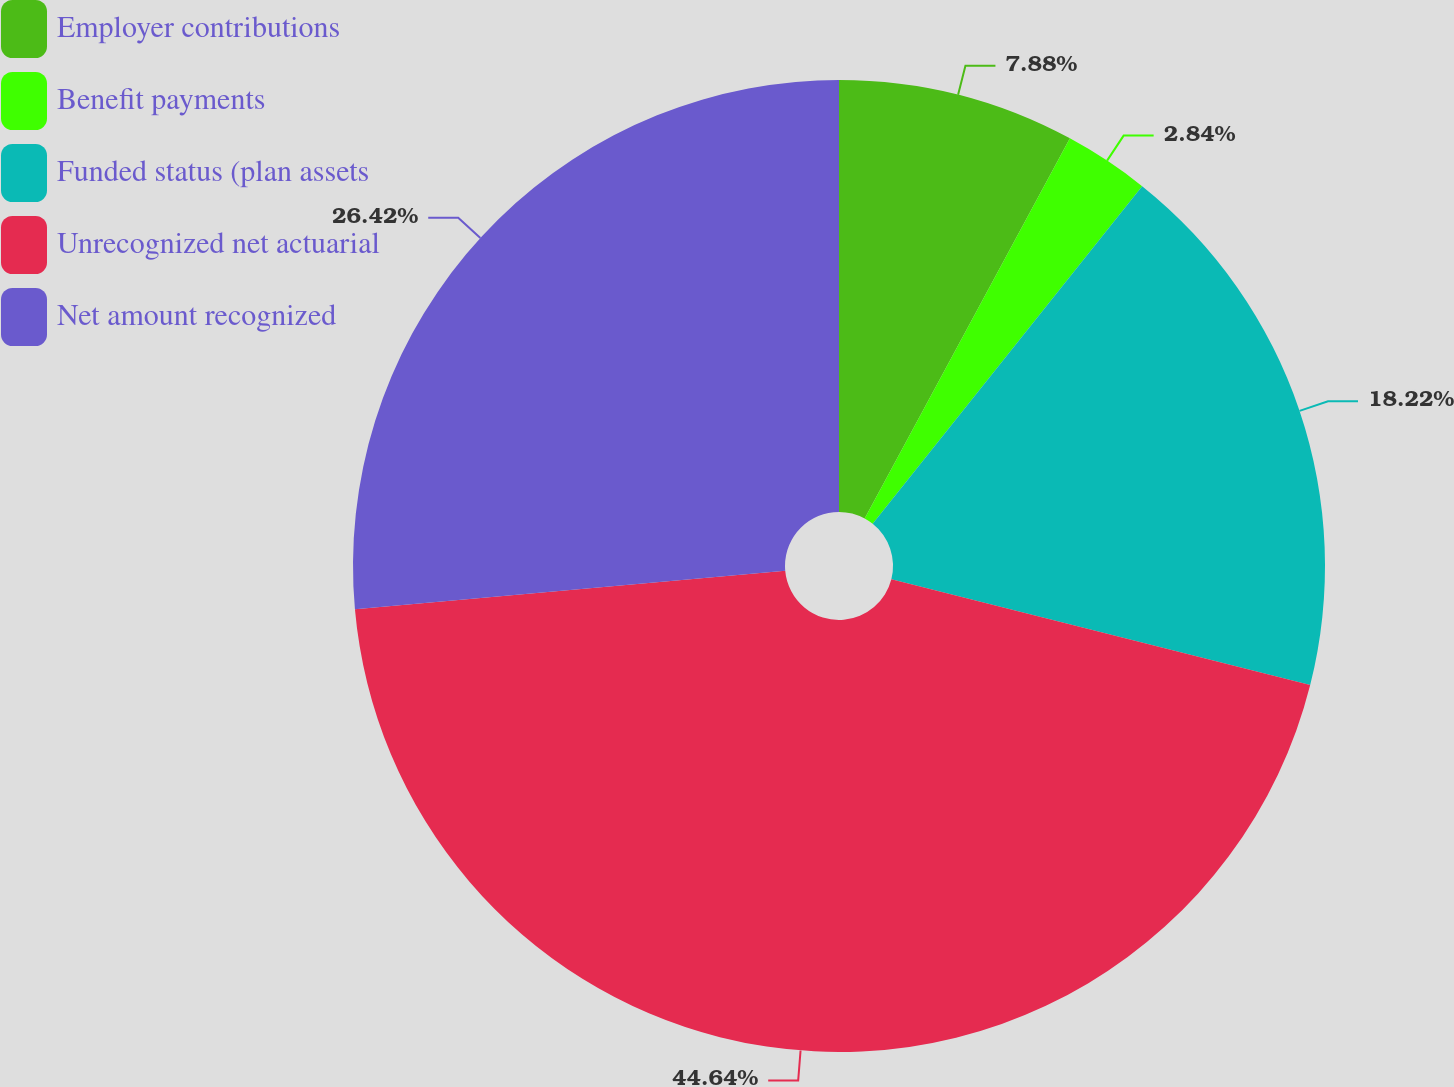Convert chart. <chart><loc_0><loc_0><loc_500><loc_500><pie_chart><fcel>Employer contributions<fcel>Benefit payments<fcel>Funded status (plan assets<fcel>Unrecognized net actuarial<fcel>Net amount recognized<nl><fcel>7.88%<fcel>2.84%<fcel>18.22%<fcel>44.64%<fcel>26.42%<nl></chart> 